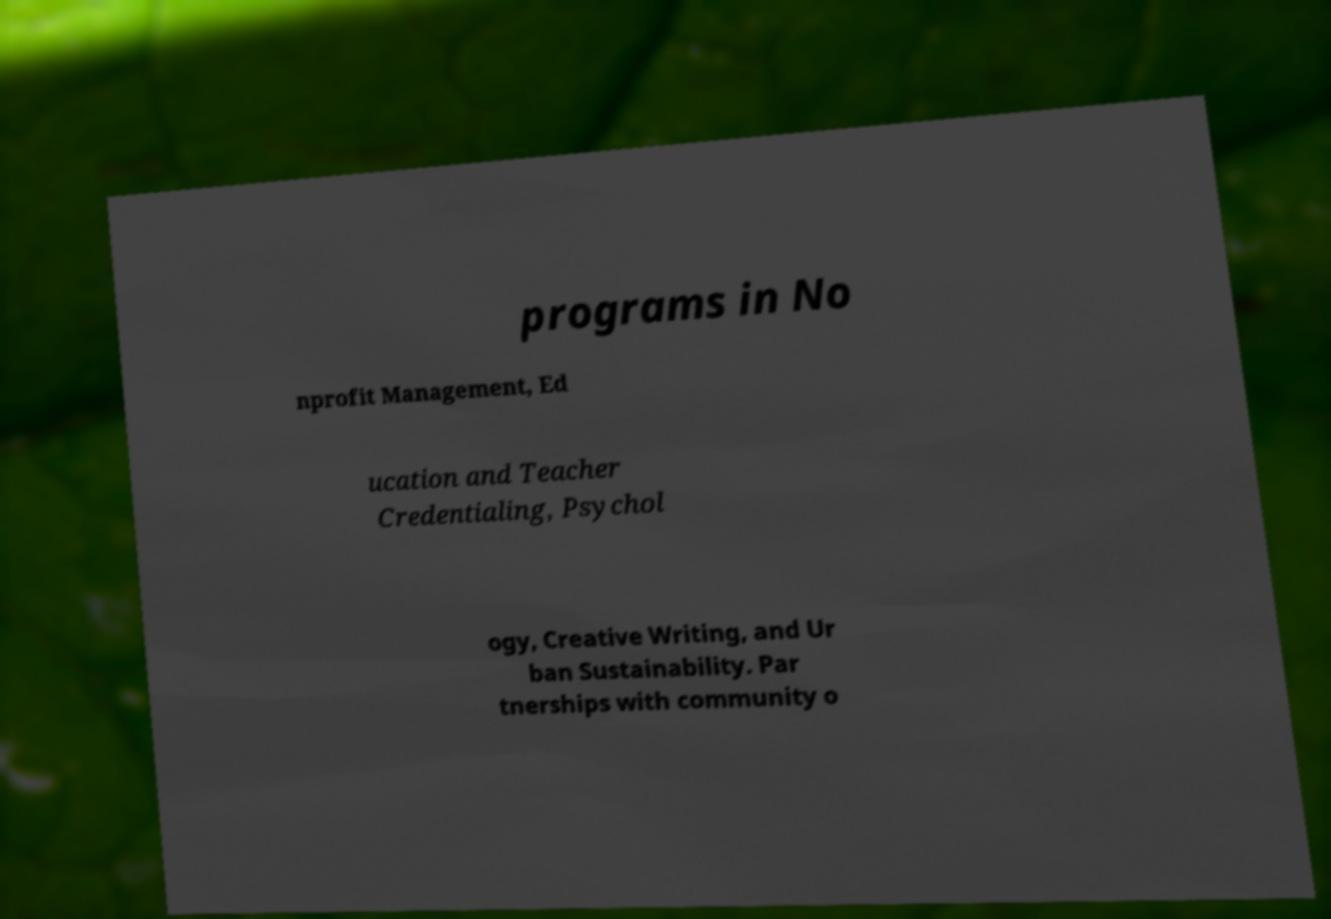What messages or text are displayed in this image? I need them in a readable, typed format. programs in No nprofit Management, Ed ucation and Teacher Credentialing, Psychol ogy, Creative Writing, and Ur ban Sustainability. Par tnerships with community o 